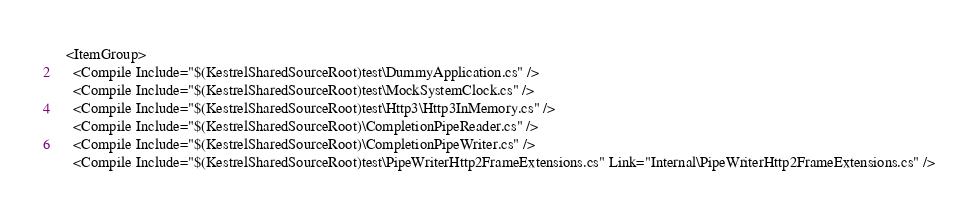Convert code to text. <code><loc_0><loc_0><loc_500><loc_500><_XML_>  <ItemGroup>
    <Compile Include="$(KestrelSharedSourceRoot)test\DummyApplication.cs" />
    <Compile Include="$(KestrelSharedSourceRoot)test\MockSystemClock.cs" />
    <Compile Include="$(KestrelSharedSourceRoot)test\Http3\Http3InMemory.cs" />
    <Compile Include="$(KestrelSharedSourceRoot)\CompletionPipeReader.cs" />
    <Compile Include="$(KestrelSharedSourceRoot)\CompletionPipeWriter.cs" />
    <Compile Include="$(KestrelSharedSourceRoot)test\PipeWriterHttp2FrameExtensions.cs" Link="Internal\PipeWriterHttp2FrameExtensions.cs" /></code> 